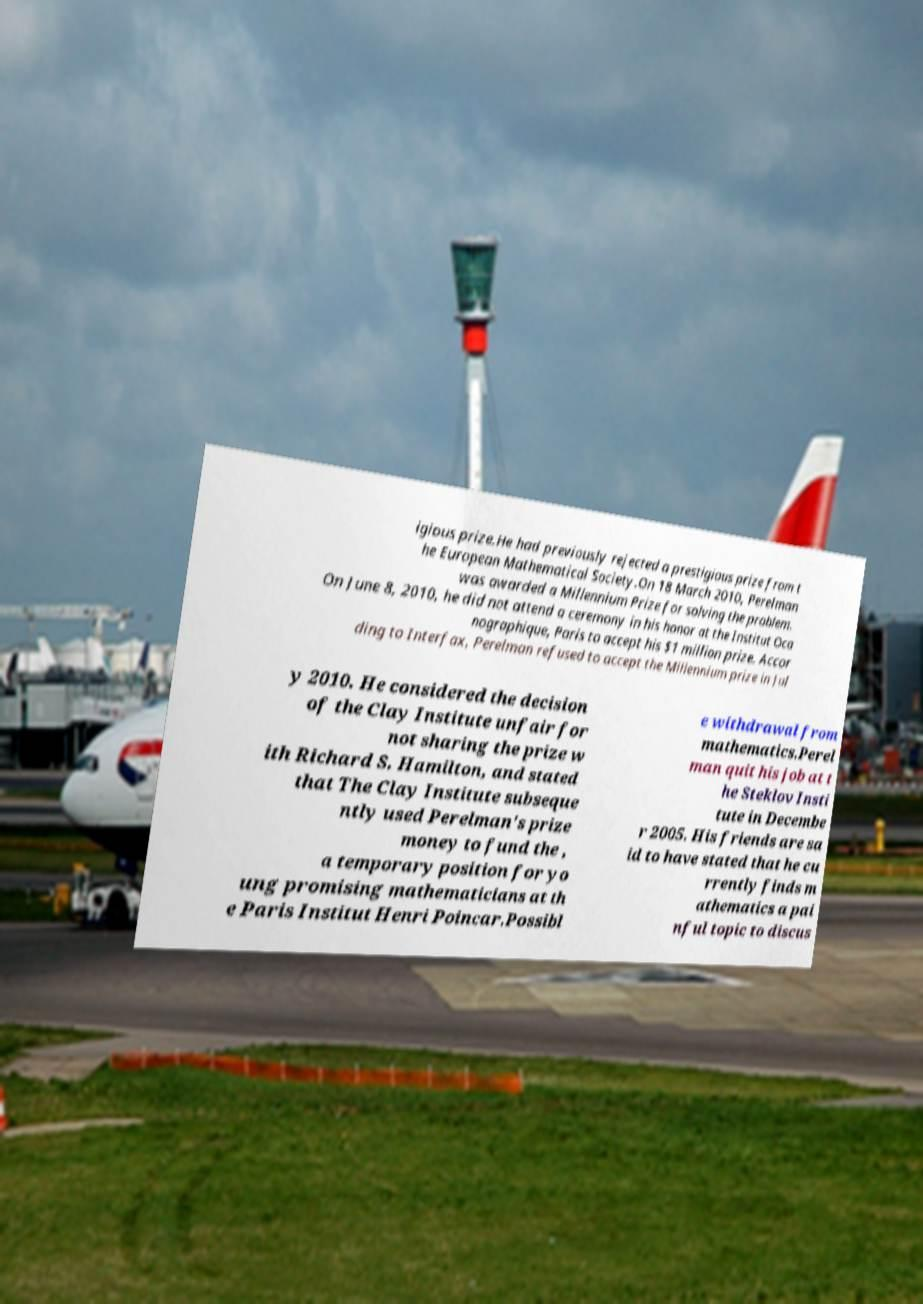Could you extract and type out the text from this image? igious prize.He had previously rejected a prestigious prize from t he European Mathematical Society.On 18 March 2010, Perelman was awarded a Millennium Prize for solving the problem. On June 8, 2010, he did not attend a ceremony in his honor at the Institut Oca nographique, Paris to accept his $1 million prize. Accor ding to Interfax, Perelman refused to accept the Millennium prize in Jul y 2010. He considered the decision of the Clay Institute unfair for not sharing the prize w ith Richard S. Hamilton, and stated that The Clay Institute subseque ntly used Perelman's prize money to fund the , a temporary position for yo ung promising mathematicians at th e Paris Institut Henri Poincar.Possibl e withdrawal from mathematics.Perel man quit his job at t he Steklov Insti tute in Decembe r 2005. His friends are sa id to have stated that he cu rrently finds m athematics a pai nful topic to discus 